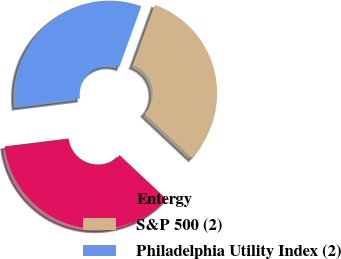<chart> <loc_0><loc_0><loc_500><loc_500><pie_chart><fcel>Entergy<fcel>S&P 500 (2)<fcel>Philadelphia Utility Index (2)<nl><fcel>36.04%<fcel>31.49%<fcel>32.48%<nl></chart> 